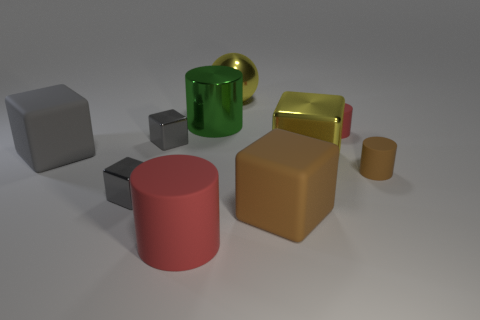Is there a tiny matte object of the same shape as the green shiny thing?
Offer a terse response. Yes. What is the shape of the big thing that is both right of the big rubber cylinder and in front of the big yellow cube?
Your answer should be compact. Cube. What number of small red things are made of the same material as the tiny brown thing?
Offer a terse response. 1. Are there fewer red matte cylinders on the right side of the green metal cylinder than red objects?
Your answer should be compact. Yes. There is a red rubber cylinder on the right side of the yellow sphere; is there a yellow object behind it?
Make the answer very short. Yes. Is there any other thing that has the same shape as the tiny red object?
Your answer should be very brief. Yes. Is the size of the yellow sphere the same as the yellow metal cube?
Offer a very short reply. Yes. There is a brown thing on the right side of the red object that is on the right side of the big cylinder in front of the brown cube; what is its material?
Offer a terse response. Rubber. Are there an equal number of brown objects that are right of the large brown rubber block and large blue cylinders?
Provide a succinct answer. No. How many things are either blocks or tiny brown rubber objects?
Make the answer very short. 6. 